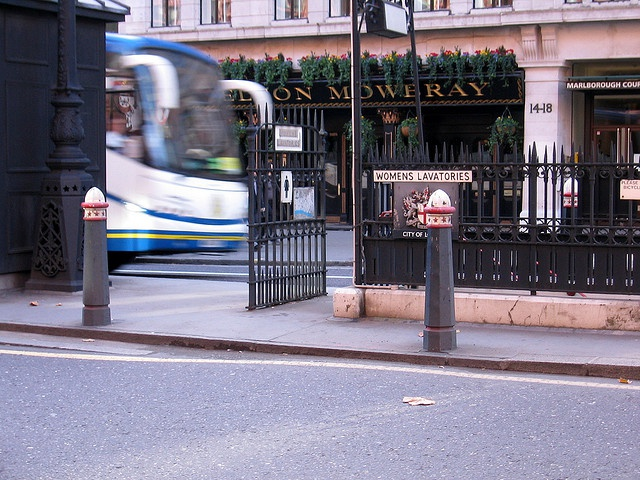Describe the objects in this image and their specific colors. I can see bus in black, lavender, gray, and darkgray tones, potted plant in black, darkgreen, gray, and teal tones, and potted plant in black, gray, teal, and darkgreen tones in this image. 